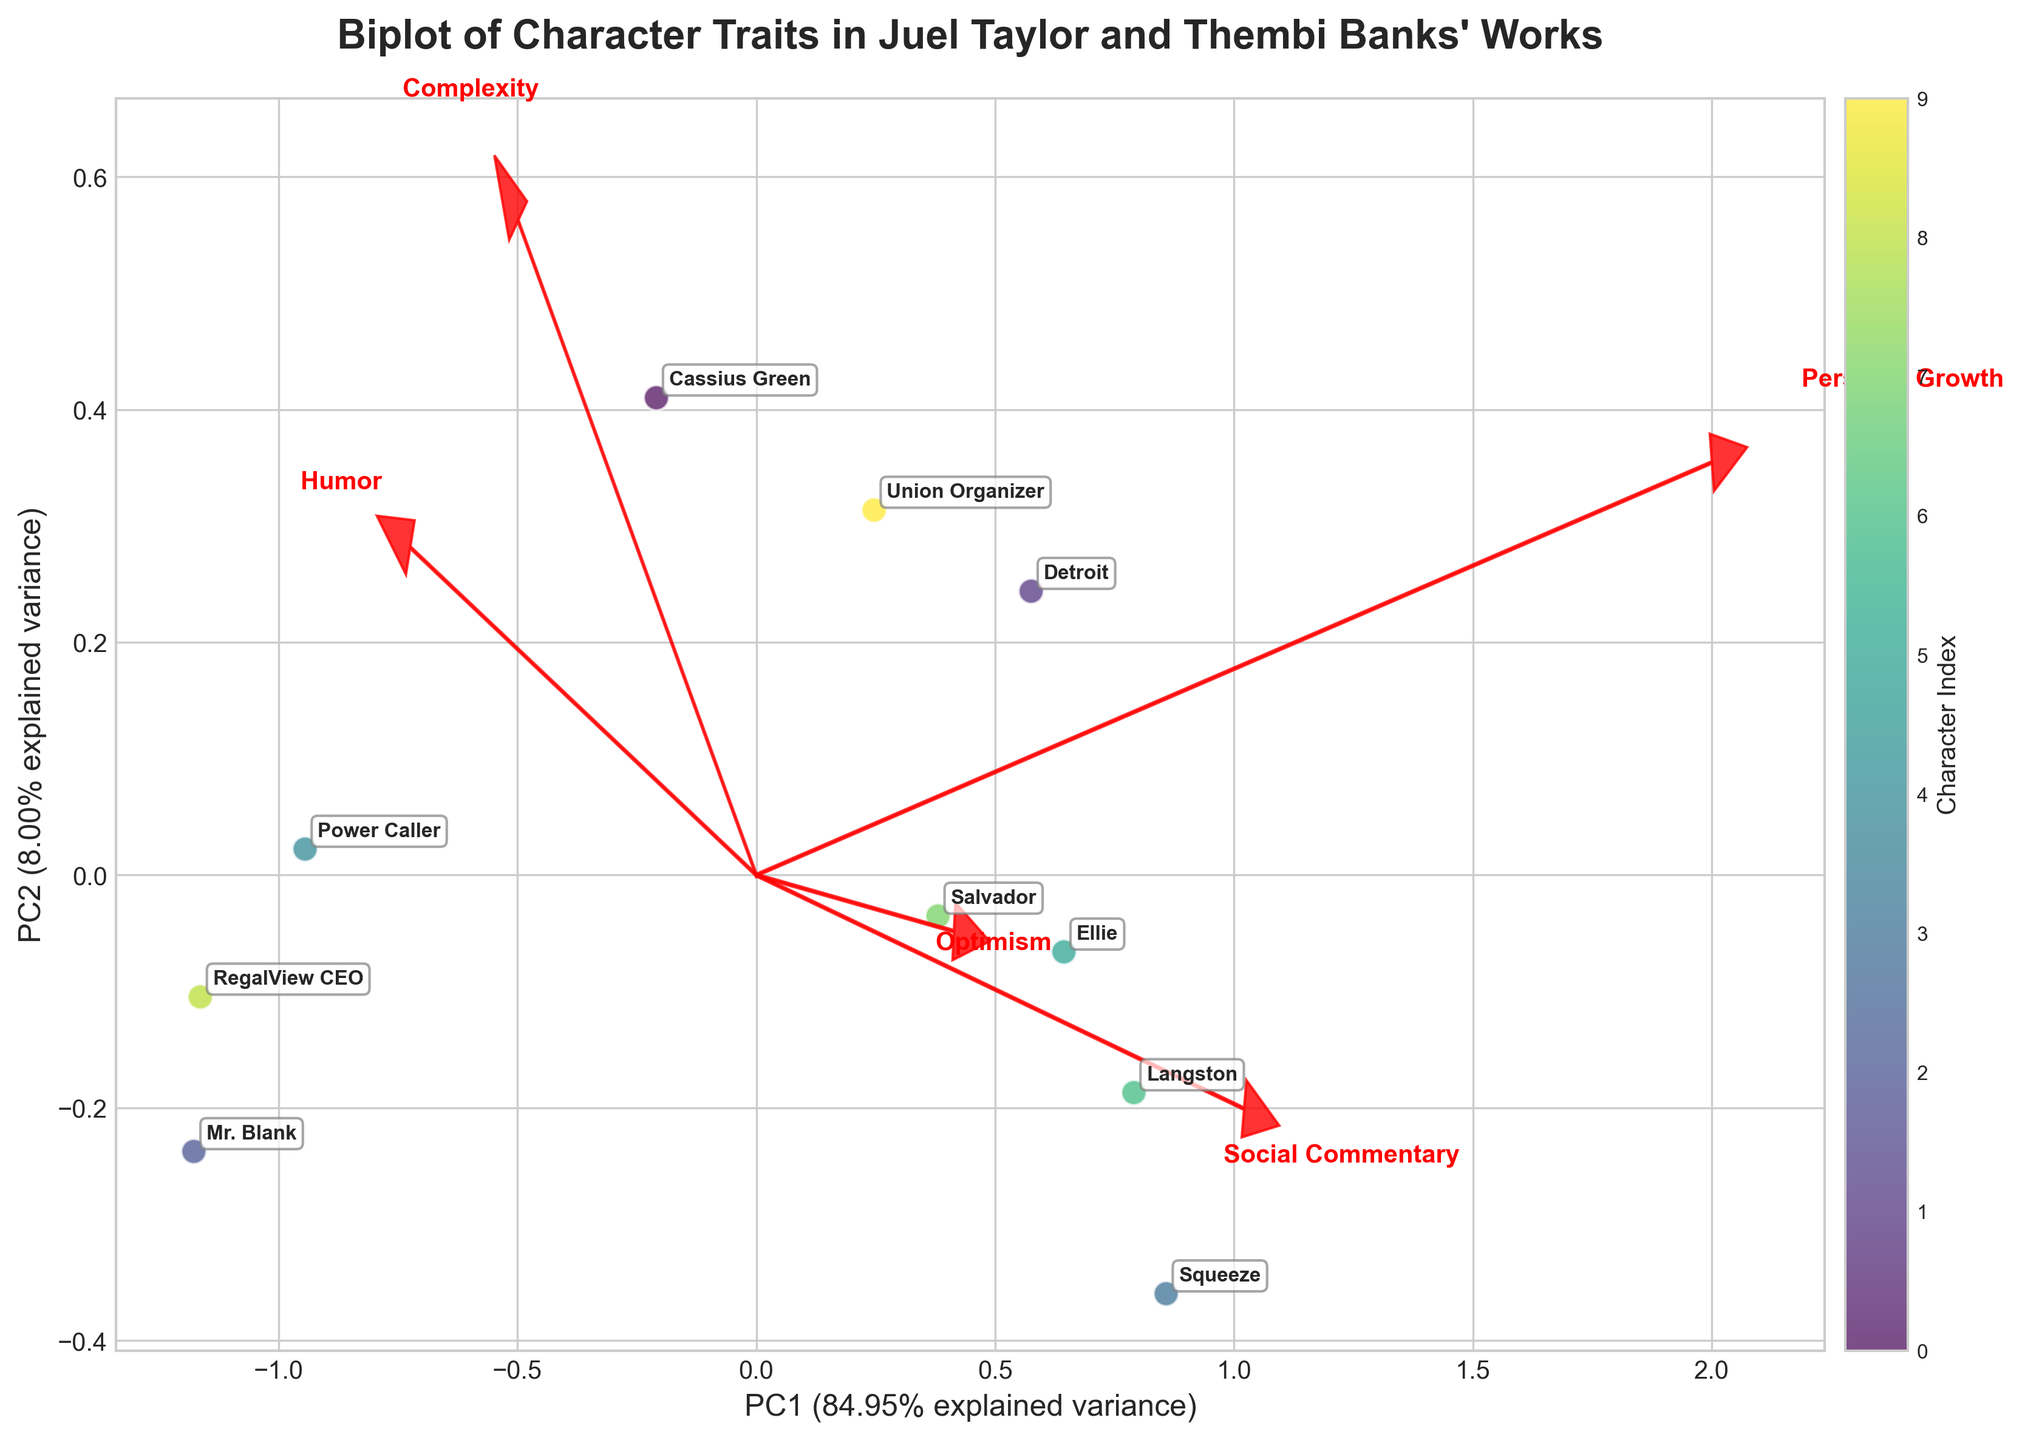What does the title of the biplot indicate? The title of the biplot is "Biplot of Character Traits in Juel Taylor and Thembi Banks' Works." It indicates that the biplot visualizes various character traits from the works of these authors.
Answer: Character Traits in Juel Taylor and Thembi Banks' Works What do the X and Y axes represent in the biplot? The X-axis and Y-axis represent the first two principal components. The labels also include the percentage of variance explained by each component.
Answer: Principal Components 1 and 2 How many character data points are shown in the biplot? There are labeled points for each character name on the biplot.
Answer: 10 Which two characters appear closest to each other in the biplot? Look at the points labeled with character names and find the pair that are closest visually.
Answer: Cassius Green and RegalView CEO Which feature vector points most strongly in the positive direction of Principal Component 1? Examine the direction of the arrows from the origin; the arrow pointing most horizontally to the right aligns with PC1.
Answer: Social Commentary Comparing Ellie and Salvador, which character shows higher Personal Growth on the biplot? Look at the position relative to the Personal Growth arrow; whichever character is placed further in that direction has higher Personal Growth.
Answer: Ellie Which feature is associated with Principal Component 2 based on the arrow directions? Check which arrows are more aligned with the Y-axis, indicating greater association with PC2.
Answer: Optimism and Social Commentary Which character has the strongest combination of Humor and Optimism traits? Find the character projected closest to where the arrows of Humor and Optimism point.
Answer: Squeeze How does Mr. Blank rate on Complexity compared to Langston? Look at the position of both characters relative to the Complexity arrow.
Answer: Mr. Blank is higher Which character is most negatively associated with Optimism? Find the character furthest in the negative direction along the Optimism vector.
Answer: Mr. Blank 